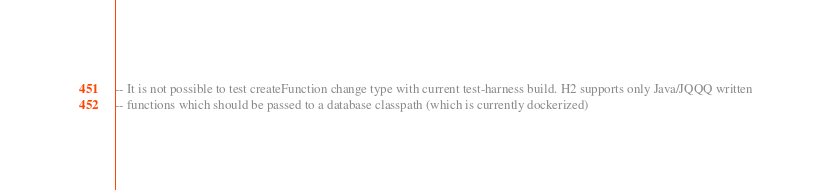<code> <loc_0><loc_0><loc_500><loc_500><_SQL_>
-- It is not possible to test createFunction change type with current test-harness build. H2 supports only Java/JQQQ written
-- functions which should be passed to a database classpath (which is currently dockerized)</code> 